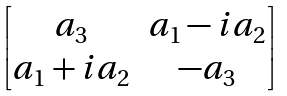Convert formula to latex. <formula><loc_0><loc_0><loc_500><loc_500>\begin{bmatrix} a _ { 3 } & a _ { 1 } - i a _ { 2 } \\ a _ { 1 } + i a _ { 2 } & - a _ { 3 } \end{bmatrix}</formula> 